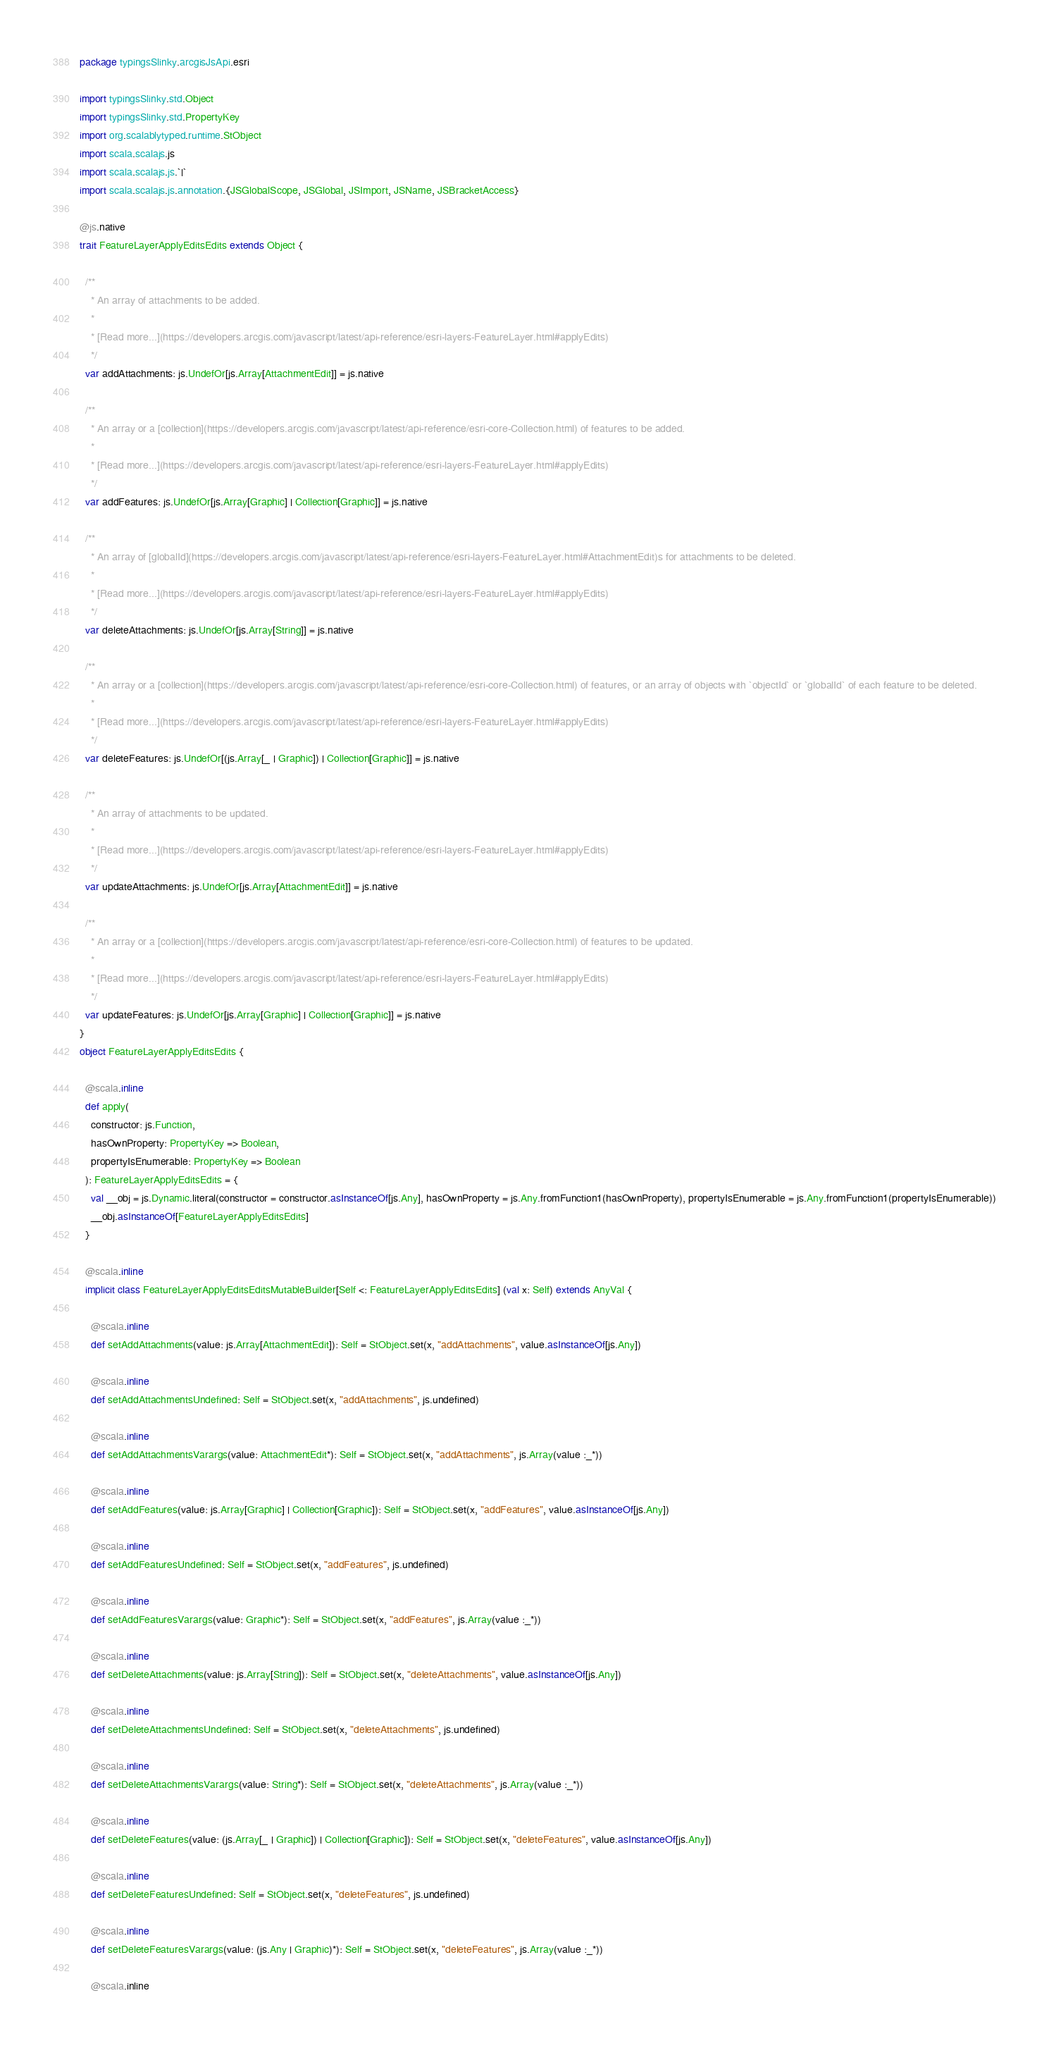<code> <loc_0><loc_0><loc_500><loc_500><_Scala_>package typingsSlinky.arcgisJsApi.esri

import typingsSlinky.std.Object
import typingsSlinky.std.PropertyKey
import org.scalablytyped.runtime.StObject
import scala.scalajs.js
import scala.scalajs.js.`|`
import scala.scalajs.js.annotation.{JSGlobalScope, JSGlobal, JSImport, JSName, JSBracketAccess}

@js.native
trait FeatureLayerApplyEditsEdits extends Object {
  
  /**
    * An array of attachments to be added.
    *
    * [Read more...](https://developers.arcgis.com/javascript/latest/api-reference/esri-layers-FeatureLayer.html#applyEdits)
    */
  var addAttachments: js.UndefOr[js.Array[AttachmentEdit]] = js.native
  
  /**
    * An array or a [collection](https://developers.arcgis.com/javascript/latest/api-reference/esri-core-Collection.html) of features to be added.
    *
    * [Read more...](https://developers.arcgis.com/javascript/latest/api-reference/esri-layers-FeatureLayer.html#applyEdits)
    */
  var addFeatures: js.UndefOr[js.Array[Graphic] | Collection[Graphic]] = js.native
  
  /**
    * An array of [globalId](https://developers.arcgis.com/javascript/latest/api-reference/esri-layers-FeatureLayer.html#AttachmentEdit)s for attachments to be deleted.
    *
    * [Read more...](https://developers.arcgis.com/javascript/latest/api-reference/esri-layers-FeatureLayer.html#applyEdits)
    */
  var deleteAttachments: js.UndefOr[js.Array[String]] = js.native
  
  /**
    * An array or a [collection](https://developers.arcgis.com/javascript/latest/api-reference/esri-core-Collection.html) of features, or an array of objects with `objectId` or `globalId` of each feature to be deleted.
    *
    * [Read more...](https://developers.arcgis.com/javascript/latest/api-reference/esri-layers-FeatureLayer.html#applyEdits)
    */
  var deleteFeatures: js.UndefOr[(js.Array[_ | Graphic]) | Collection[Graphic]] = js.native
  
  /**
    * An array of attachments to be updated.
    *
    * [Read more...](https://developers.arcgis.com/javascript/latest/api-reference/esri-layers-FeatureLayer.html#applyEdits)
    */
  var updateAttachments: js.UndefOr[js.Array[AttachmentEdit]] = js.native
  
  /**
    * An array or a [collection](https://developers.arcgis.com/javascript/latest/api-reference/esri-core-Collection.html) of features to be updated.
    *
    * [Read more...](https://developers.arcgis.com/javascript/latest/api-reference/esri-layers-FeatureLayer.html#applyEdits)
    */
  var updateFeatures: js.UndefOr[js.Array[Graphic] | Collection[Graphic]] = js.native
}
object FeatureLayerApplyEditsEdits {
  
  @scala.inline
  def apply(
    constructor: js.Function,
    hasOwnProperty: PropertyKey => Boolean,
    propertyIsEnumerable: PropertyKey => Boolean
  ): FeatureLayerApplyEditsEdits = {
    val __obj = js.Dynamic.literal(constructor = constructor.asInstanceOf[js.Any], hasOwnProperty = js.Any.fromFunction1(hasOwnProperty), propertyIsEnumerable = js.Any.fromFunction1(propertyIsEnumerable))
    __obj.asInstanceOf[FeatureLayerApplyEditsEdits]
  }
  
  @scala.inline
  implicit class FeatureLayerApplyEditsEditsMutableBuilder[Self <: FeatureLayerApplyEditsEdits] (val x: Self) extends AnyVal {
    
    @scala.inline
    def setAddAttachments(value: js.Array[AttachmentEdit]): Self = StObject.set(x, "addAttachments", value.asInstanceOf[js.Any])
    
    @scala.inline
    def setAddAttachmentsUndefined: Self = StObject.set(x, "addAttachments", js.undefined)
    
    @scala.inline
    def setAddAttachmentsVarargs(value: AttachmentEdit*): Self = StObject.set(x, "addAttachments", js.Array(value :_*))
    
    @scala.inline
    def setAddFeatures(value: js.Array[Graphic] | Collection[Graphic]): Self = StObject.set(x, "addFeatures", value.asInstanceOf[js.Any])
    
    @scala.inline
    def setAddFeaturesUndefined: Self = StObject.set(x, "addFeatures", js.undefined)
    
    @scala.inline
    def setAddFeaturesVarargs(value: Graphic*): Self = StObject.set(x, "addFeatures", js.Array(value :_*))
    
    @scala.inline
    def setDeleteAttachments(value: js.Array[String]): Self = StObject.set(x, "deleteAttachments", value.asInstanceOf[js.Any])
    
    @scala.inline
    def setDeleteAttachmentsUndefined: Self = StObject.set(x, "deleteAttachments", js.undefined)
    
    @scala.inline
    def setDeleteAttachmentsVarargs(value: String*): Self = StObject.set(x, "deleteAttachments", js.Array(value :_*))
    
    @scala.inline
    def setDeleteFeatures(value: (js.Array[_ | Graphic]) | Collection[Graphic]): Self = StObject.set(x, "deleteFeatures", value.asInstanceOf[js.Any])
    
    @scala.inline
    def setDeleteFeaturesUndefined: Self = StObject.set(x, "deleteFeatures", js.undefined)
    
    @scala.inline
    def setDeleteFeaturesVarargs(value: (js.Any | Graphic)*): Self = StObject.set(x, "deleteFeatures", js.Array(value :_*))
    
    @scala.inline</code> 